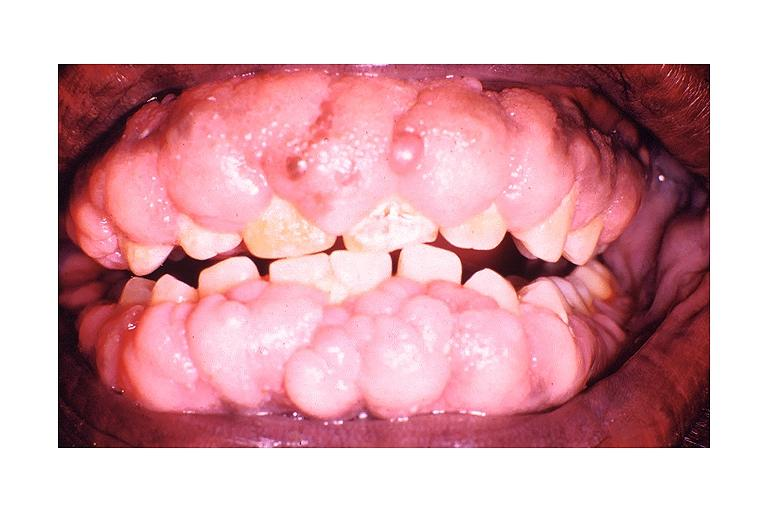what does this image show?
Answer the question using a single word or phrase. Dilantin induced gingival hyperplasia 